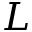<formula> <loc_0><loc_0><loc_500><loc_500>L</formula> 